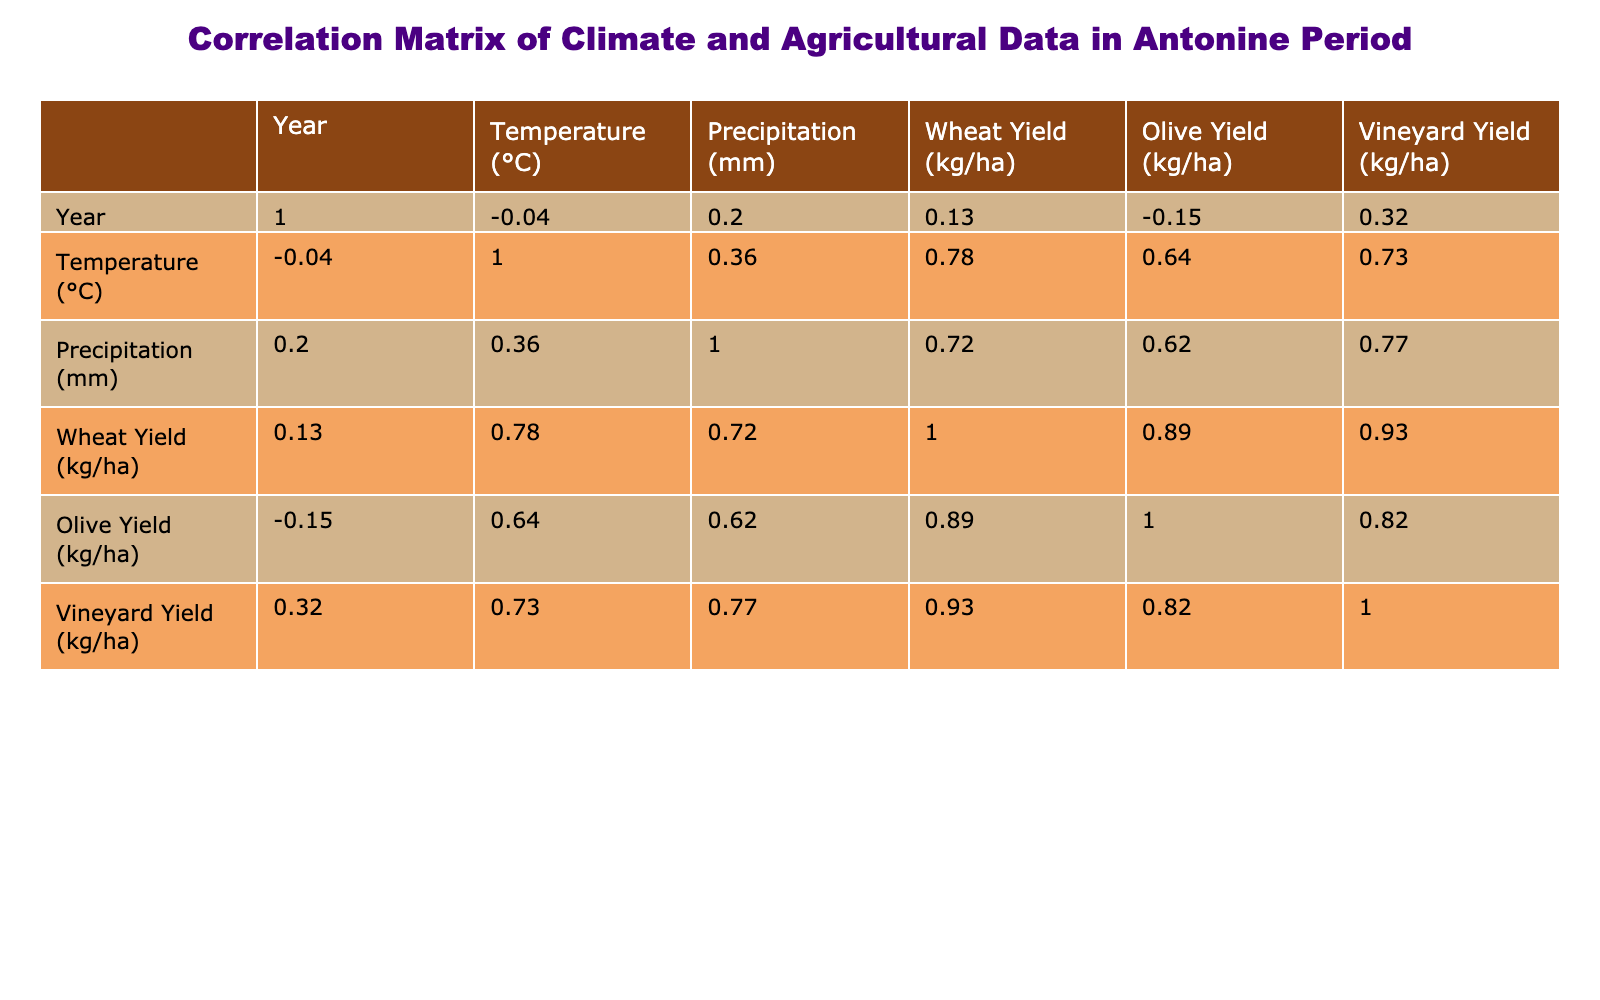What is the correlation between temperature and wheat yield? From the table, the correlation coefficient value between temperature and wheat yield is 0.75. This means there is a positive correlation: as temperature increases, wheat yield tends to increase as well.
Answer: 0.75 What is the correlation between precipitation and olive yield? From the table, the correlation coefficient between precipitation and olive yield is 0.50. This indicates a moderate positive correlation: an increase in precipitation is associated with an increase in olive yield.
Answer: 0.50 Was the highest wheat yield observed in a year with the highest temperature? To answer this, we look for the year with the highest wheat yield, which is 950 kg/ha in 154 (temperature 17.3°C). The highest temperature recorded in the table is 18.1°C in 157, where the wheat yield is lower (930 kg/ha). Therefore, the highest wheat yield does not correspond to the highest temperature.
Answer: No What was the average olive yield over the years provided? To calculate the average olive yield, we sum the olive yields (900 + 950 + 880 + 920 + 970 + 940 + 850 + 910 + 900 + 890 + 930) = 10300 kg/ha and divide by the number of years (11), giving an average of 935.45 kg/ha, which is rounded to 935 kg/ha.
Answer: 935 In which year was the lowest precipitation recorded, and what was the associated wheat yield for that year? The lowest precipitation recorded is 490 mm in 156, and the associated wheat yield for that year is 780 kg/ha. This means that even with low precipitation, wheat yield was notably low as well.
Answer: 156, 780 kg/ha Which year experienced both the highest temperature and the highest olive yield? From the data, the year 157 experienced the highest temperature of 18.1°C with an olive yield of 910 kg/ha, which is not the highest olive yield. The highest olive yield was in 154 (970 kg/ha), which had a lower temperature (17.3°C). Thus, no single year holds both highest metrics simultaneously.
Answer: None What is the correlation between vineyard yield and temperature? The correlation coefficient between vineyard yield and temperature is 0.77. This indicates a strong positive correlation, suggesting that higher temperatures correlate with increased vineyard yields.
Answer: 0.77 How does the average temperature of years with a wheat yield above 900 kg/ha compare to those below? The years with wheat yields above 900 kg/ha are 151 (18.0°C), 154 (17.3°C), 155 (17.7°C), 157 (18.1°C), and 160 (17.6°C); The average temperature for these years is 17.74°C. The years with wheat yields below 900 are 150, 152, 153, 156, 158, and 159, with an average temperature of 17.13°C. The years with higher wheat yields are warmer on average.
Answer: 17.74°C vs 17.13°C What was the relationship between precipitation and wheat yield across the years? The correlation coefficient between precipitation and wheat yield is 0.40, indicating a weak positive relationship. This suggests that while there is a slight tendency for higher precipitation to align with higher yields, it is not a strong relationship, implying that other factors also influence wheat yield significantly.
Answer: 0.40 